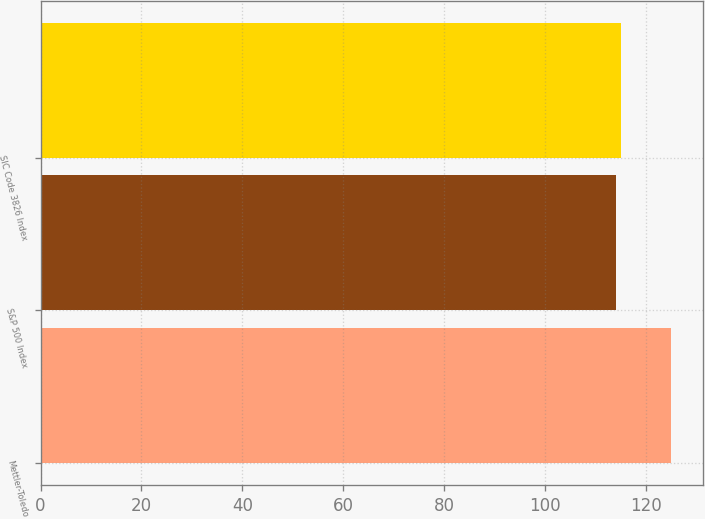Convert chart to OTSL. <chart><loc_0><loc_0><loc_500><loc_500><bar_chart><fcel>Mettler-Toledo<fcel>S&P 500 Index<fcel>SIC Code 3826 Index<nl><fcel>125<fcel>114<fcel>115.1<nl></chart> 